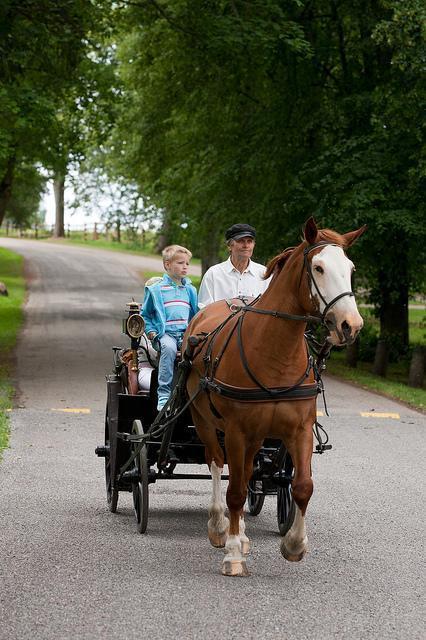How many people can you see?
Give a very brief answer. 2. How many people are in the carriage?
Give a very brief answer. 2. How many children are in the wagon?
Give a very brief answer. 1. How many people are there?
Give a very brief answer. 2. How many people are in the picture?
Give a very brief answer. 2. 